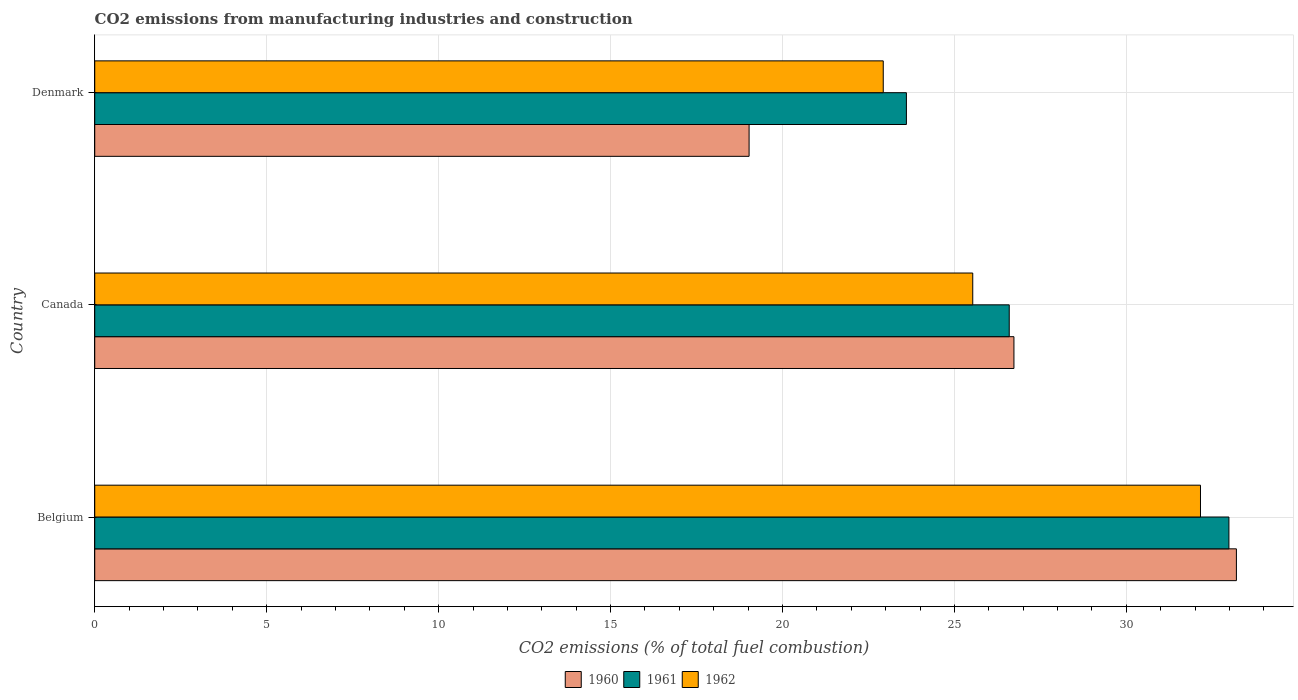How many different coloured bars are there?
Ensure brevity in your answer.  3. How many groups of bars are there?
Provide a succinct answer. 3. How many bars are there on the 1st tick from the top?
Your answer should be compact. 3. What is the label of the 1st group of bars from the top?
Provide a short and direct response. Denmark. In how many cases, is the number of bars for a given country not equal to the number of legend labels?
Keep it short and to the point. 0. What is the amount of CO2 emitted in 1961 in Canada?
Your response must be concise. 26.59. Across all countries, what is the maximum amount of CO2 emitted in 1962?
Your answer should be very brief. 32.16. Across all countries, what is the minimum amount of CO2 emitted in 1960?
Provide a short and direct response. 19.03. What is the total amount of CO2 emitted in 1960 in the graph?
Offer a terse response. 78.96. What is the difference between the amount of CO2 emitted in 1960 in Belgium and that in Denmark?
Ensure brevity in your answer.  14.17. What is the difference between the amount of CO2 emitted in 1961 in Canada and the amount of CO2 emitted in 1962 in Belgium?
Make the answer very short. -5.56. What is the average amount of CO2 emitted in 1962 per country?
Your answer should be very brief. 26.87. What is the difference between the amount of CO2 emitted in 1962 and amount of CO2 emitted in 1960 in Belgium?
Offer a very short reply. -1.04. In how many countries, is the amount of CO2 emitted in 1962 greater than 23 %?
Offer a very short reply. 2. What is the ratio of the amount of CO2 emitted in 1961 in Belgium to that in Denmark?
Give a very brief answer. 1.4. Is the amount of CO2 emitted in 1961 in Canada less than that in Denmark?
Provide a short and direct response. No. What is the difference between the highest and the second highest amount of CO2 emitted in 1961?
Your response must be concise. 6.39. What is the difference between the highest and the lowest amount of CO2 emitted in 1962?
Offer a terse response. 9.23. In how many countries, is the amount of CO2 emitted in 1961 greater than the average amount of CO2 emitted in 1961 taken over all countries?
Your answer should be very brief. 1. What does the 2nd bar from the top in Belgium represents?
Your answer should be very brief. 1961. How many bars are there?
Your response must be concise. 9. What is the difference between two consecutive major ticks on the X-axis?
Offer a terse response. 5. Are the values on the major ticks of X-axis written in scientific E-notation?
Your answer should be very brief. No. Does the graph contain grids?
Give a very brief answer. Yes. Where does the legend appear in the graph?
Offer a very short reply. Bottom center. How are the legend labels stacked?
Provide a succinct answer. Horizontal. What is the title of the graph?
Your answer should be compact. CO2 emissions from manufacturing industries and construction. What is the label or title of the X-axis?
Provide a succinct answer. CO2 emissions (% of total fuel combustion). What is the CO2 emissions (% of total fuel combustion) in 1960 in Belgium?
Your answer should be very brief. 33.2. What is the CO2 emissions (% of total fuel combustion) in 1961 in Belgium?
Keep it short and to the point. 32.98. What is the CO2 emissions (% of total fuel combustion) of 1962 in Belgium?
Your answer should be compact. 32.16. What is the CO2 emissions (% of total fuel combustion) in 1960 in Canada?
Ensure brevity in your answer.  26.73. What is the CO2 emissions (% of total fuel combustion) in 1961 in Canada?
Your answer should be compact. 26.59. What is the CO2 emissions (% of total fuel combustion) of 1962 in Canada?
Your response must be concise. 25.53. What is the CO2 emissions (% of total fuel combustion) in 1960 in Denmark?
Provide a succinct answer. 19.03. What is the CO2 emissions (% of total fuel combustion) of 1961 in Denmark?
Your answer should be compact. 23.6. What is the CO2 emissions (% of total fuel combustion) in 1962 in Denmark?
Offer a very short reply. 22.93. Across all countries, what is the maximum CO2 emissions (% of total fuel combustion) of 1960?
Give a very brief answer. 33.2. Across all countries, what is the maximum CO2 emissions (% of total fuel combustion) of 1961?
Your answer should be very brief. 32.98. Across all countries, what is the maximum CO2 emissions (% of total fuel combustion) of 1962?
Your answer should be very brief. 32.16. Across all countries, what is the minimum CO2 emissions (% of total fuel combustion) in 1960?
Your response must be concise. 19.03. Across all countries, what is the minimum CO2 emissions (% of total fuel combustion) of 1961?
Offer a very short reply. 23.6. Across all countries, what is the minimum CO2 emissions (% of total fuel combustion) of 1962?
Make the answer very short. 22.93. What is the total CO2 emissions (% of total fuel combustion) of 1960 in the graph?
Provide a succinct answer. 78.96. What is the total CO2 emissions (% of total fuel combustion) in 1961 in the graph?
Offer a very short reply. 83.18. What is the total CO2 emissions (% of total fuel combustion) of 1962 in the graph?
Provide a succinct answer. 80.62. What is the difference between the CO2 emissions (% of total fuel combustion) in 1960 in Belgium and that in Canada?
Your response must be concise. 6.47. What is the difference between the CO2 emissions (% of total fuel combustion) in 1961 in Belgium and that in Canada?
Ensure brevity in your answer.  6.39. What is the difference between the CO2 emissions (% of total fuel combustion) of 1962 in Belgium and that in Canada?
Provide a succinct answer. 6.62. What is the difference between the CO2 emissions (% of total fuel combustion) of 1960 in Belgium and that in Denmark?
Ensure brevity in your answer.  14.17. What is the difference between the CO2 emissions (% of total fuel combustion) in 1961 in Belgium and that in Denmark?
Keep it short and to the point. 9.38. What is the difference between the CO2 emissions (% of total fuel combustion) of 1962 in Belgium and that in Denmark?
Your response must be concise. 9.23. What is the difference between the CO2 emissions (% of total fuel combustion) of 1960 in Canada and that in Denmark?
Your response must be concise. 7.7. What is the difference between the CO2 emissions (% of total fuel combustion) in 1961 in Canada and that in Denmark?
Your answer should be compact. 2.99. What is the difference between the CO2 emissions (% of total fuel combustion) in 1962 in Canada and that in Denmark?
Make the answer very short. 2.6. What is the difference between the CO2 emissions (% of total fuel combustion) of 1960 in Belgium and the CO2 emissions (% of total fuel combustion) of 1961 in Canada?
Keep it short and to the point. 6.61. What is the difference between the CO2 emissions (% of total fuel combustion) in 1960 in Belgium and the CO2 emissions (% of total fuel combustion) in 1962 in Canada?
Your response must be concise. 7.67. What is the difference between the CO2 emissions (% of total fuel combustion) in 1961 in Belgium and the CO2 emissions (% of total fuel combustion) in 1962 in Canada?
Make the answer very short. 7.45. What is the difference between the CO2 emissions (% of total fuel combustion) of 1960 in Belgium and the CO2 emissions (% of total fuel combustion) of 1961 in Denmark?
Your answer should be compact. 9.6. What is the difference between the CO2 emissions (% of total fuel combustion) in 1960 in Belgium and the CO2 emissions (% of total fuel combustion) in 1962 in Denmark?
Make the answer very short. 10.27. What is the difference between the CO2 emissions (% of total fuel combustion) in 1961 in Belgium and the CO2 emissions (% of total fuel combustion) in 1962 in Denmark?
Keep it short and to the point. 10.05. What is the difference between the CO2 emissions (% of total fuel combustion) of 1960 in Canada and the CO2 emissions (% of total fuel combustion) of 1961 in Denmark?
Make the answer very short. 3.13. What is the difference between the CO2 emissions (% of total fuel combustion) of 1960 in Canada and the CO2 emissions (% of total fuel combustion) of 1962 in Denmark?
Your answer should be compact. 3.8. What is the difference between the CO2 emissions (% of total fuel combustion) of 1961 in Canada and the CO2 emissions (% of total fuel combustion) of 1962 in Denmark?
Your response must be concise. 3.66. What is the average CO2 emissions (% of total fuel combustion) of 1960 per country?
Provide a short and direct response. 26.32. What is the average CO2 emissions (% of total fuel combustion) of 1961 per country?
Your response must be concise. 27.73. What is the average CO2 emissions (% of total fuel combustion) in 1962 per country?
Ensure brevity in your answer.  26.87. What is the difference between the CO2 emissions (% of total fuel combustion) in 1960 and CO2 emissions (% of total fuel combustion) in 1961 in Belgium?
Offer a very short reply. 0.22. What is the difference between the CO2 emissions (% of total fuel combustion) in 1960 and CO2 emissions (% of total fuel combustion) in 1962 in Belgium?
Provide a short and direct response. 1.04. What is the difference between the CO2 emissions (% of total fuel combustion) in 1961 and CO2 emissions (% of total fuel combustion) in 1962 in Belgium?
Provide a short and direct response. 0.83. What is the difference between the CO2 emissions (% of total fuel combustion) of 1960 and CO2 emissions (% of total fuel combustion) of 1961 in Canada?
Offer a terse response. 0.14. What is the difference between the CO2 emissions (% of total fuel combustion) in 1960 and CO2 emissions (% of total fuel combustion) in 1962 in Canada?
Give a very brief answer. 1.2. What is the difference between the CO2 emissions (% of total fuel combustion) of 1961 and CO2 emissions (% of total fuel combustion) of 1962 in Canada?
Offer a very short reply. 1.06. What is the difference between the CO2 emissions (% of total fuel combustion) of 1960 and CO2 emissions (% of total fuel combustion) of 1961 in Denmark?
Give a very brief answer. -4.57. What is the difference between the CO2 emissions (% of total fuel combustion) in 1960 and CO2 emissions (% of total fuel combustion) in 1962 in Denmark?
Ensure brevity in your answer.  -3.9. What is the difference between the CO2 emissions (% of total fuel combustion) of 1961 and CO2 emissions (% of total fuel combustion) of 1962 in Denmark?
Provide a short and direct response. 0.67. What is the ratio of the CO2 emissions (% of total fuel combustion) of 1960 in Belgium to that in Canada?
Provide a short and direct response. 1.24. What is the ratio of the CO2 emissions (% of total fuel combustion) in 1961 in Belgium to that in Canada?
Offer a very short reply. 1.24. What is the ratio of the CO2 emissions (% of total fuel combustion) in 1962 in Belgium to that in Canada?
Ensure brevity in your answer.  1.26. What is the ratio of the CO2 emissions (% of total fuel combustion) in 1960 in Belgium to that in Denmark?
Your response must be concise. 1.74. What is the ratio of the CO2 emissions (% of total fuel combustion) of 1961 in Belgium to that in Denmark?
Ensure brevity in your answer.  1.4. What is the ratio of the CO2 emissions (% of total fuel combustion) of 1962 in Belgium to that in Denmark?
Your response must be concise. 1.4. What is the ratio of the CO2 emissions (% of total fuel combustion) in 1960 in Canada to that in Denmark?
Offer a terse response. 1.4. What is the ratio of the CO2 emissions (% of total fuel combustion) of 1961 in Canada to that in Denmark?
Your answer should be compact. 1.13. What is the ratio of the CO2 emissions (% of total fuel combustion) in 1962 in Canada to that in Denmark?
Your answer should be compact. 1.11. What is the difference between the highest and the second highest CO2 emissions (% of total fuel combustion) in 1960?
Your response must be concise. 6.47. What is the difference between the highest and the second highest CO2 emissions (% of total fuel combustion) in 1961?
Provide a succinct answer. 6.39. What is the difference between the highest and the second highest CO2 emissions (% of total fuel combustion) of 1962?
Your answer should be very brief. 6.62. What is the difference between the highest and the lowest CO2 emissions (% of total fuel combustion) in 1960?
Make the answer very short. 14.17. What is the difference between the highest and the lowest CO2 emissions (% of total fuel combustion) in 1961?
Your response must be concise. 9.38. What is the difference between the highest and the lowest CO2 emissions (% of total fuel combustion) in 1962?
Your answer should be very brief. 9.23. 